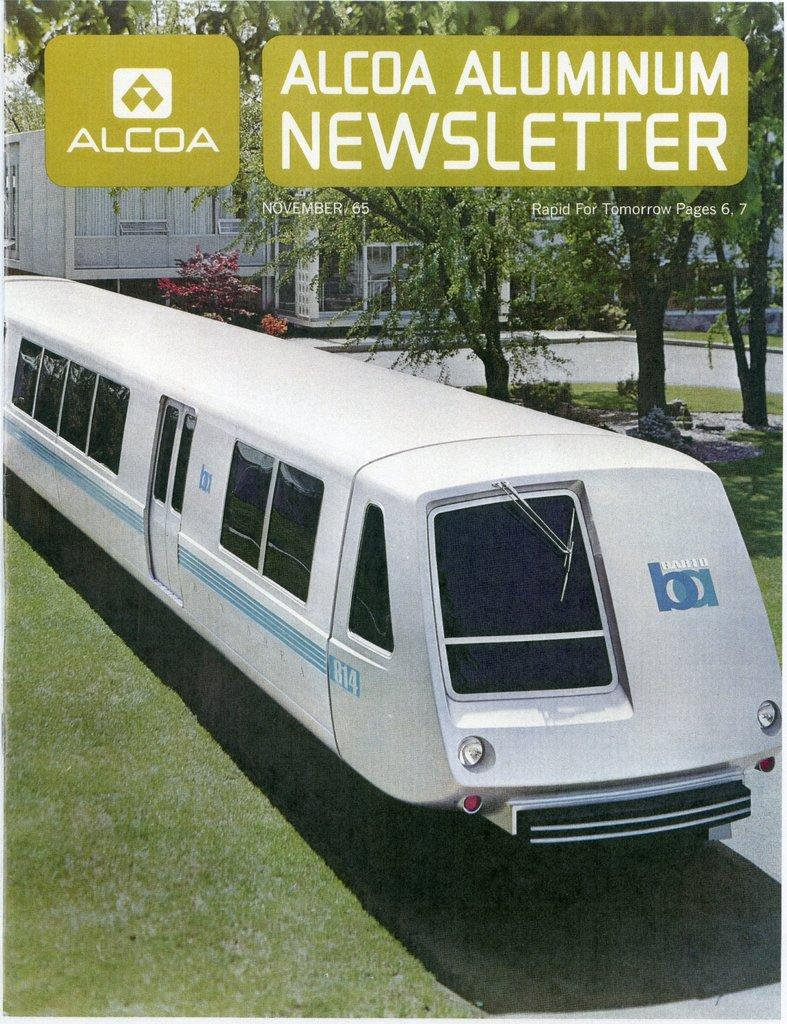What is the main subject in the front of the image? There is a vehicle in the front of the image. What type of natural environment is visible in the front of the image? There is grass in the front of the image. What can be seen in the background of the image? There are buildings, plants, and trees in the background of the image. Are there any watermarks present in the image? Yes, there are watermarks at the top of the image. What type of prose is being recited by the trees in the background of the image? There is no prose or any form of recitation present in the image; it only features a vehicle, grass, buildings, plants, trees, and watermarks. 